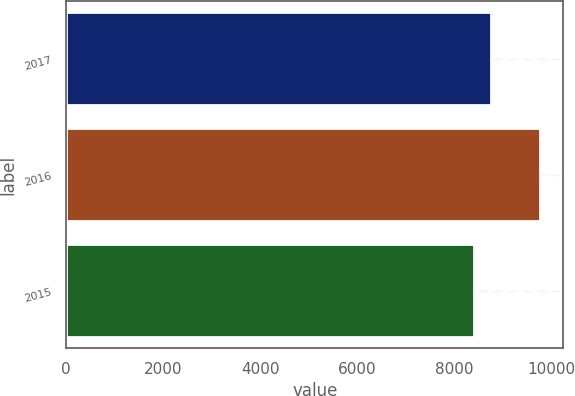Convert chart. <chart><loc_0><loc_0><loc_500><loc_500><bar_chart><fcel>2017<fcel>2016<fcel>2015<nl><fcel>8746<fcel>9755<fcel>8390<nl></chart> 